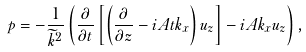Convert formula to latex. <formula><loc_0><loc_0><loc_500><loc_500>p = - \frac { 1 } { \widetilde { k } ^ { 2 } } \left ( \frac { \partial } { \partial t } \left [ \left ( \frac { \partial } { \partial z } - i A t k _ { x } \right ) u _ { z } \right ] - i A k _ { x } u _ { z } \right ) ,</formula> 